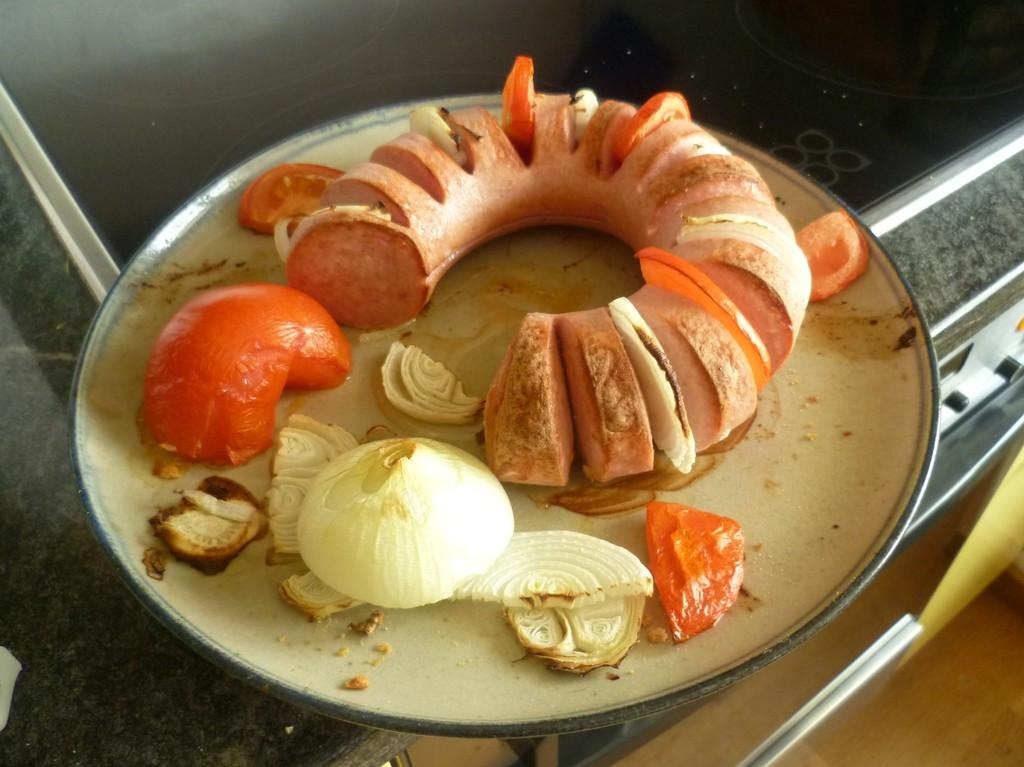What type of food item containing meat can be seen in the image? There is a food item containing meat in the image, but the specific type cannot be determined from the facts provided. What other ingredients are visible in the image? There are tomato pieces and onion pieces in the image. How are the food items arranged in the image? The food items are placed on a plate. What is the color of the surface the plate is placed on? The plate is placed on a black surface. What appliance is visible in the image? There is a microwave visible in the image. What type of flooring is present in the image? There is a wooden floor in the image. Who is the creator of the arithmetic problem seen on the plate in the image? There is no arithmetic problem visible on the plate in the image. What mode of transport is used to deliver the food items in the image? The facts provided do not mention any mode of transport for the food items. 